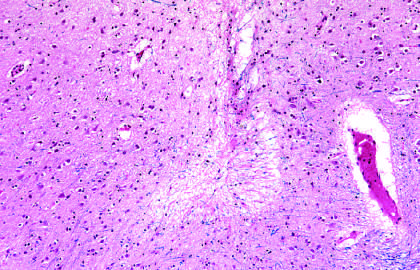re old intracortical infarcts seen as areas of tissue loss and residual gliosis?
Answer the question using a single word or phrase. Yes 